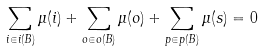<formula> <loc_0><loc_0><loc_500><loc_500>\sum _ { i \in i ( B ) } \mu ( i ) + \sum _ { o \in o ( B ) } \mu ( o ) + \sum _ { p \in p ( B ) } \mu ( s ) = 0</formula> 